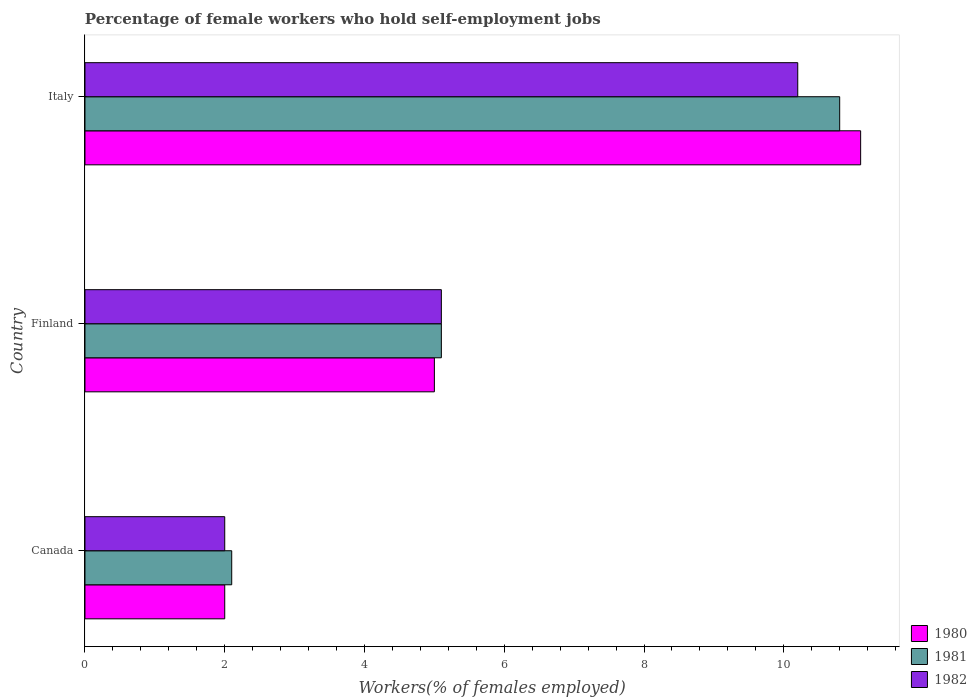How many groups of bars are there?
Offer a terse response. 3. Are the number of bars per tick equal to the number of legend labels?
Offer a very short reply. Yes. Are the number of bars on each tick of the Y-axis equal?
Keep it short and to the point. Yes. How many bars are there on the 1st tick from the top?
Offer a terse response. 3. How many bars are there on the 1st tick from the bottom?
Your answer should be compact. 3. What is the label of the 1st group of bars from the top?
Offer a terse response. Italy. In how many cases, is the number of bars for a given country not equal to the number of legend labels?
Provide a short and direct response. 0. What is the percentage of self-employed female workers in 1981 in Finland?
Ensure brevity in your answer.  5.1. Across all countries, what is the maximum percentage of self-employed female workers in 1982?
Your response must be concise. 10.2. Across all countries, what is the minimum percentage of self-employed female workers in 1980?
Give a very brief answer. 2. In which country was the percentage of self-employed female workers in 1981 maximum?
Offer a terse response. Italy. In which country was the percentage of self-employed female workers in 1980 minimum?
Ensure brevity in your answer.  Canada. What is the total percentage of self-employed female workers in 1981 in the graph?
Make the answer very short. 18. What is the difference between the percentage of self-employed female workers in 1980 in Canada and that in Finland?
Offer a very short reply. -3. What is the difference between the percentage of self-employed female workers in 1981 in Italy and the percentage of self-employed female workers in 1980 in Finland?
Your answer should be compact. 5.8. What is the average percentage of self-employed female workers in 1980 per country?
Offer a terse response. 6.03. What is the difference between the percentage of self-employed female workers in 1981 and percentage of self-employed female workers in 1982 in Canada?
Provide a succinct answer. 0.1. What is the ratio of the percentage of self-employed female workers in 1980 in Finland to that in Italy?
Your answer should be compact. 0.45. Is the percentage of self-employed female workers in 1982 in Canada less than that in Italy?
Offer a terse response. Yes. Is the difference between the percentage of self-employed female workers in 1981 in Canada and Italy greater than the difference between the percentage of self-employed female workers in 1982 in Canada and Italy?
Provide a short and direct response. No. What is the difference between the highest and the second highest percentage of self-employed female workers in 1981?
Provide a short and direct response. 5.7. What is the difference between the highest and the lowest percentage of self-employed female workers in 1980?
Give a very brief answer. 9.1. What does the 1st bar from the top in Italy represents?
Your response must be concise. 1982. Are all the bars in the graph horizontal?
Give a very brief answer. Yes. How many countries are there in the graph?
Provide a succinct answer. 3. Are the values on the major ticks of X-axis written in scientific E-notation?
Make the answer very short. No. Does the graph contain any zero values?
Your response must be concise. No. Where does the legend appear in the graph?
Your response must be concise. Bottom right. How many legend labels are there?
Provide a short and direct response. 3. What is the title of the graph?
Offer a very short reply. Percentage of female workers who hold self-employment jobs. What is the label or title of the X-axis?
Offer a very short reply. Workers(% of females employed). What is the label or title of the Y-axis?
Your response must be concise. Country. What is the Workers(% of females employed) of 1980 in Canada?
Your response must be concise. 2. What is the Workers(% of females employed) in 1981 in Canada?
Offer a terse response. 2.1. What is the Workers(% of females employed) in 1981 in Finland?
Ensure brevity in your answer.  5.1. What is the Workers(% of females employed) of 1982 in Finland?
Your answer should be compact. 5.1. What is the Workers(% of females employed) in 1980 in Italy?
Offer a very short reply. 11.1. What is the Workers(% of females employed) of 1981 in Italy?
Your answer should be compact. 10.8. What is the Workers(% of females employed) in 1982 in Italy?
Provide a succinct answer. 10.2. Across all countries, what is the maximum Workers(% of females employed) in 1980?
Provide a succinct answer. 11.1. Across all countries, what is the maximum Workers(% of females employed) of 1981?
Ensure brevity in your answer.  10.8. Across all countries, what is the maximum Workers(% of females employed) in 1982?
Offer a terse response. 10.2. Across all countries, what is the minimum Workers(% of females employed) of 1981?
Your answer should be very brief. 2.1. What is the total Workers(% of females employed) in 1980 in the graph?
Give a very brief answer. 18.1. What is the total Workers(% of females employed) of 1982 in the graph?
Provide a short and direct response. 17.3. What is the difference between the Workers(% of females employed) of 1982 in Canada and that in Finland?
Your response must be concise. -3.1. What is the difference between the Workers(% of females employed) in 1980 in Canada and that in Italy?
Provide a short and direct response. -9.1. What is the difference between the Workers(% of females employed) of 1981 in Canada and that in Italy?
Give a very brief answer. -8.7. What is the difference between the Workers(% of females employed) of 1981 in Finland and that in Italy?
Offer a terse response. -5.7. What is the difference between the Workers(% of females employed) of 1980 in Canada and the Workers(% of females employed) of 1981 in Finland?
Offer a terse response. -3.1. What is the difference between the Workers(% of females employed) of 1981 in Canada and the Workers(% of females employed) of 1982 in Finland?
Offer a terse response. -3. What is the difference between the Workers(% of females employed) of 1981 in Canada and the Workers(% of females employed) of 1982 in Italy?
Make the answer very short. -8.1. What is the difference between the Workers(% of females employed) of 1980 in Finland and the Workers(% of females employed) of 1981 in Italy?
Offer a very short reply. -5.8. What is the average Workers(% of females employed) of 1980 per country?
Your response must be concise. 6.03. What is the average Workers(% of females employed) of 1982 per country?
Ensure brevity in your answer.  5.77. What is the difference between the Workers(% of females employed) of 1980 and Workers(% of females employed) of 1982 in Finland?
Ensure brevity in your answer.  -0.1. What is the difference between the Workers(% of females employed) in 1980 and Workers(% of females employed) in 1982 in Italy?
Your answer should be compact. 0.9. What is the difference between the Workers(% of females employed) in 1981 and Workers(% of females employed) in 1982 in Italy?
Offer a very short reply. 0.6. What is the ratio of the Workers(% of females employed) of 1980 in Canada to that in Finland?
Keep it short and to the point. 0.4. What is the ratio of the Workers(% of females employed) in 1981 in Canada to that in Finland?
Ensure brevity in your answer.  0.41. What is the ratio of the Workers(% of females employed) of 1982 in Canada to that in Finland?
Your answer should be compact. 0.39. What is the ratio of the Workers(% of females employed) of 1980 in Canada to that in Italy?
Provide a succinct answer. 0.18. What is the ratio of the Workers(% of females employed) of 1981 in Canada to that in Italy?
Offer a very short reply. 0.19. What is the ratio of the Workers(% of females employed) in 1982 in Canada to that in Italy?
Ensure brevity in your answer.  0.2. What is the ratio of the Workers(% of females employed) in 1980 in Finland to that in Italy?
Make the answer very short. 0.45. What is the ratio of the Workers(% of females employed) in 1981 in Finland to that in Italy?
Provide a succinct answer. 0.47. What is the difference between the highest and the second highest Workers(% of females employed) in 1980?
Your answer should be very brief. 6.1. What is the difference between the highest and the second highest Workers(% of females employed) in 1981?
Offer a terse response. 5.7. What is the difference between the highest and the second highest Workers(% of females employed) in 1982?
Keep it short and to the point. 5.1. What is the difference between the highest and the lowest Workers(% of females employed) in 1982?
Provide a short and direct response. 8.2. 